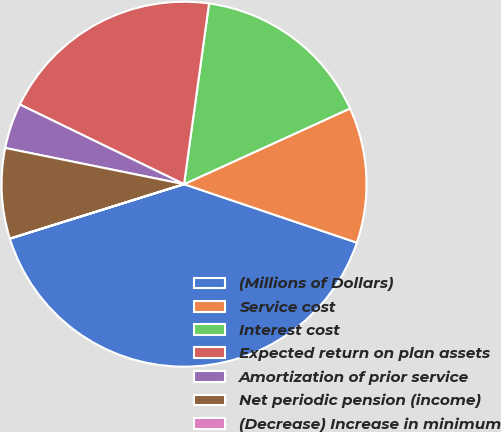Convert chart to OTSL. <chart><loc_0><loc_0><loc_500><loc_500><pie_chart><fcel>(Millions of Dollars)<fcel>Service cost<fcel>Interest cost<fcel>Expected return on plan assets<fcel>Amortization of prior service<fcel>Net periodic pension (income)<fcel>(Decrease) Increase in minimum<nl><fcel>39.98%<fcel>12.0%<fcel>16.0%<fcel>20.0%<fcel>4.01%<fcel>8.0%<fcel>0.01%<nl></chart> 